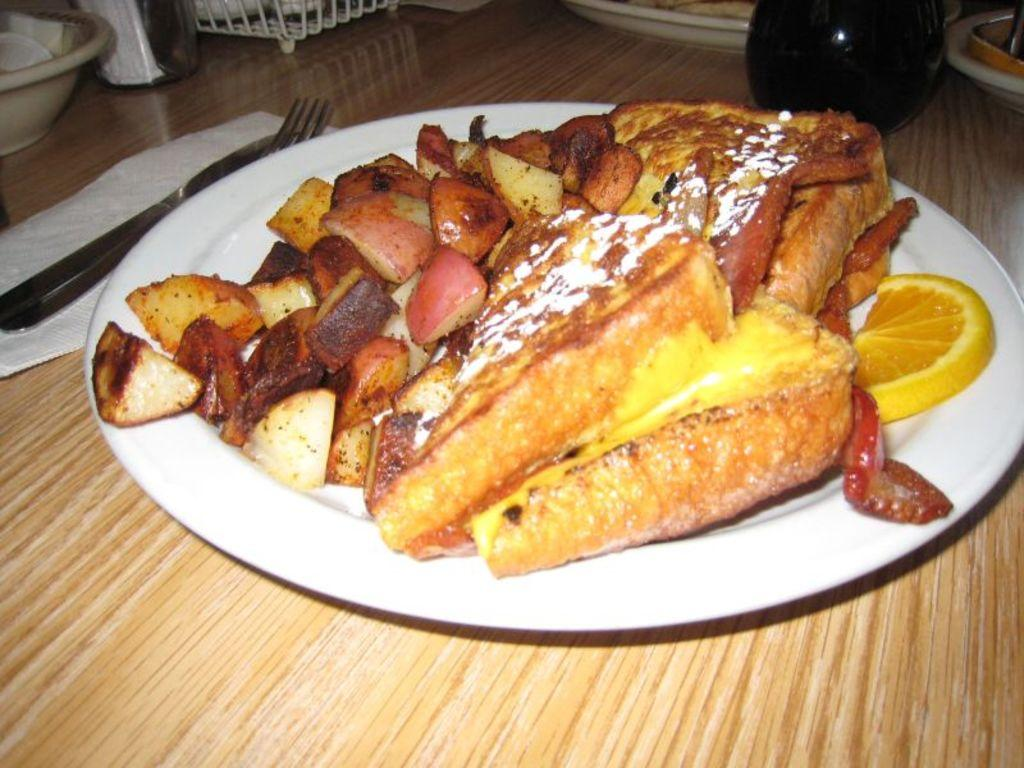What is on the plate that is visible in the image? There is a plate with food items in the image. What utensils are present in the image? There is a fork and a knife in the image. What can be used for cleaning or wiping in the image? Tissue paper is present in the image for cleaning or wiping. What is the container for holding additional food items in the image? There is a bowl in the image. What is the surface on which all these items are placed? All these items are placed on a table. What event is being described in the image? The image does not depict an event; it shows a plate with food items, utensils, tissue paper, a bowl, and other objects placed on a table. What account number is associated with the food items in the image? There is no account number associated with the food items in the image; it is a still image of various items placed on a table. 